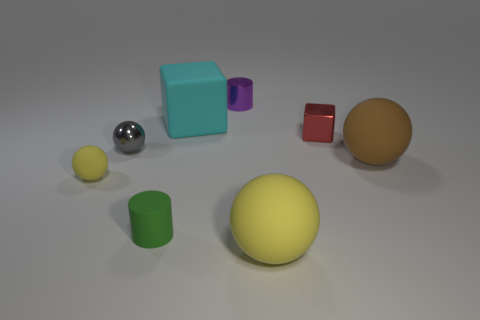Can you describe the textures and materials visible in the image? In the image, we observe several objects with different apparent textures. The silver sphere has a reflective, mirrored surface, which suggests it is metallic. The yellow and brown spheres seem to have matte surfaces, indicating non-reflective materials like rubber or plastic. The green and red cubes also appear matte, suggesting a similar material. The cyan cube has a slightly reflective surface that could imply a smoother plastic or painted wood. 